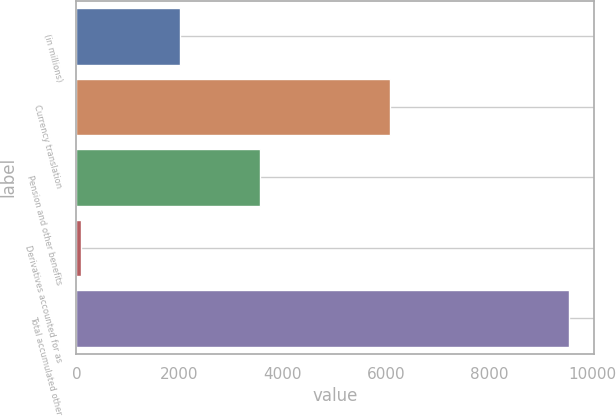Convert chart to OTSL. <chart><loc_0><loc_0><loc_500><loc_500><bar_chart><fcel>(in millions)<fcel>Currency translation<fcel>Pension and other benefits<fcel>Derivatives accounted for as<fcel>Total accumulated other<nl><fcel>2016<fcel>6091<fcel>3565<fcel>97<fcel>9559<nl></chart> 